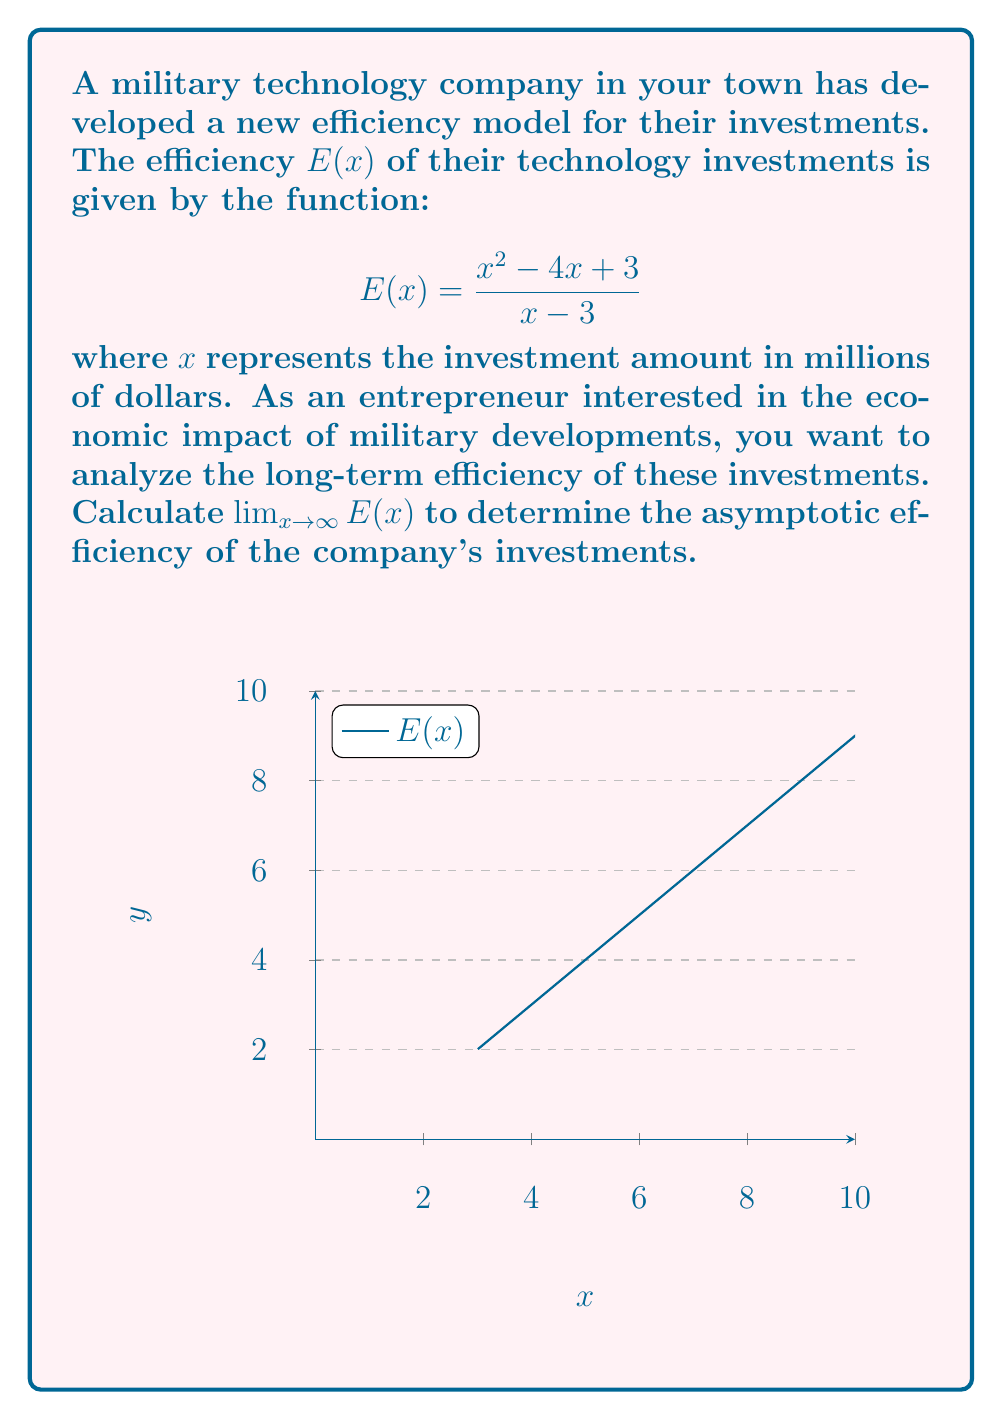Show me your answer to this math problem. To find the limit of $E(x)$ as $x$ approaches infinity, we'll follow these steps:

1) First, let's examine the function:
   $$E(x) = \frac{x^2 - 4x + 3}{x - 3}$$

2) As $x$ approaches infinity, both the numerator and denominator will grow, so we need to compare their growth rates.

3) Divide both the numerator and denominator by the highest power of $x$ in the denominator, which is $x$:

   $$\lim_{x \to \infty} E(x) = \lim_{x \to \infty} \frac{x^2 - 4x + 3}{x - 3} = \lim_{x \to \infty} \frac{\frac{x^2}{x} - \frac{4x}{x} + \frac{3}{x}}{\frac{x}{x} - \frac{3}{x}}$$

4) Simplify:
   $$\lim_{x \to \infty} \frac{x - 4 + \frac{3}{x}}{1 - \frac{3}{x}}$$

5) As $x$ approaches infinity, $\frac{3}{x}$ approaches 0:
   $$\lim_{x \to \infty} \frac{x - 4 + 0}{1 - 0} = \lim_{x \to \infty} (x - 4)$$

6) The limit of $x - 4$ as $x$ approaches infinity is infinity.

Therefore, the asymptotic efficiency of the company's investments grows without bound as the investment amount increases.
Answer: $\lim_{x \to \infty} E(x) = \infty$ 